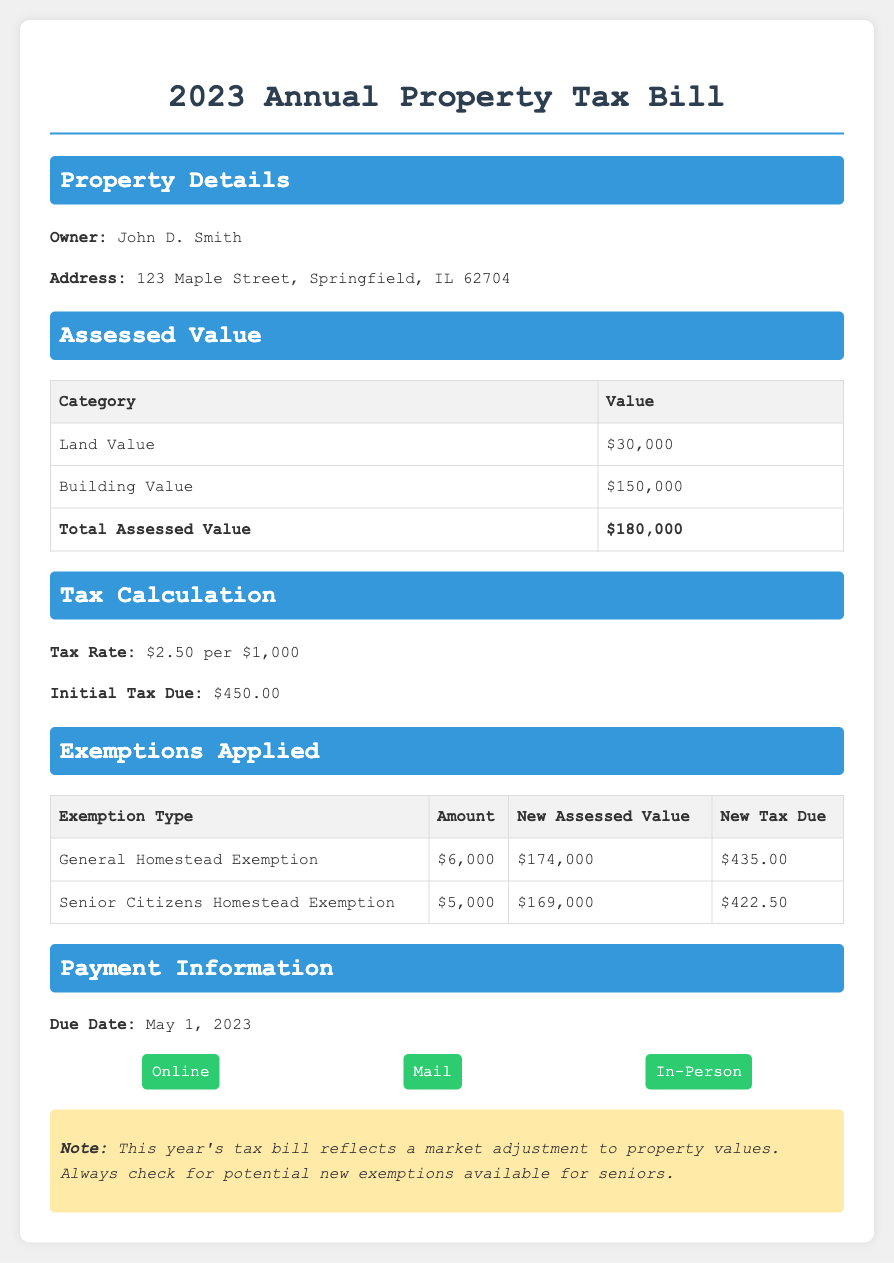What is the owner's name? The owner's name is listed at the top under Property Details.
Answer: John D. Smith What is the address? The address is provided in the Property Details section of the document.
Answer: 123 Maple Street, Springfield, IL 62704 What is the total assessed value? The total assessed value is calculated by adding the land value and building value together.
Answer: $180,000 What is the tax rate? The tax rate is specified in the Tax Calculation section of the document.
Answer: $2.50 per $1,000 What is the amount of the General Homestead Exemption? The amount of the General Homestead Exemption is noted in the Exemptions Applied section.
Answer: $6,000 What is the new tax due after exemptions? The new tax due is the amount after exemptions have been applied, as shown in the Exemptions Applied section.
Answer: $422.50 When is the payment due? The due date for payment is mentioned in the Payment Information section.
Answer: May 1, 2023 How many exemptions are applied? The number of exemptions is indicated by the rows in the Exemptions Applied table.
Answer: 2 What is the initial tax due? The initial tax due before any exemptions is stated in the Tax Calculation section.
Answer: $450.00 